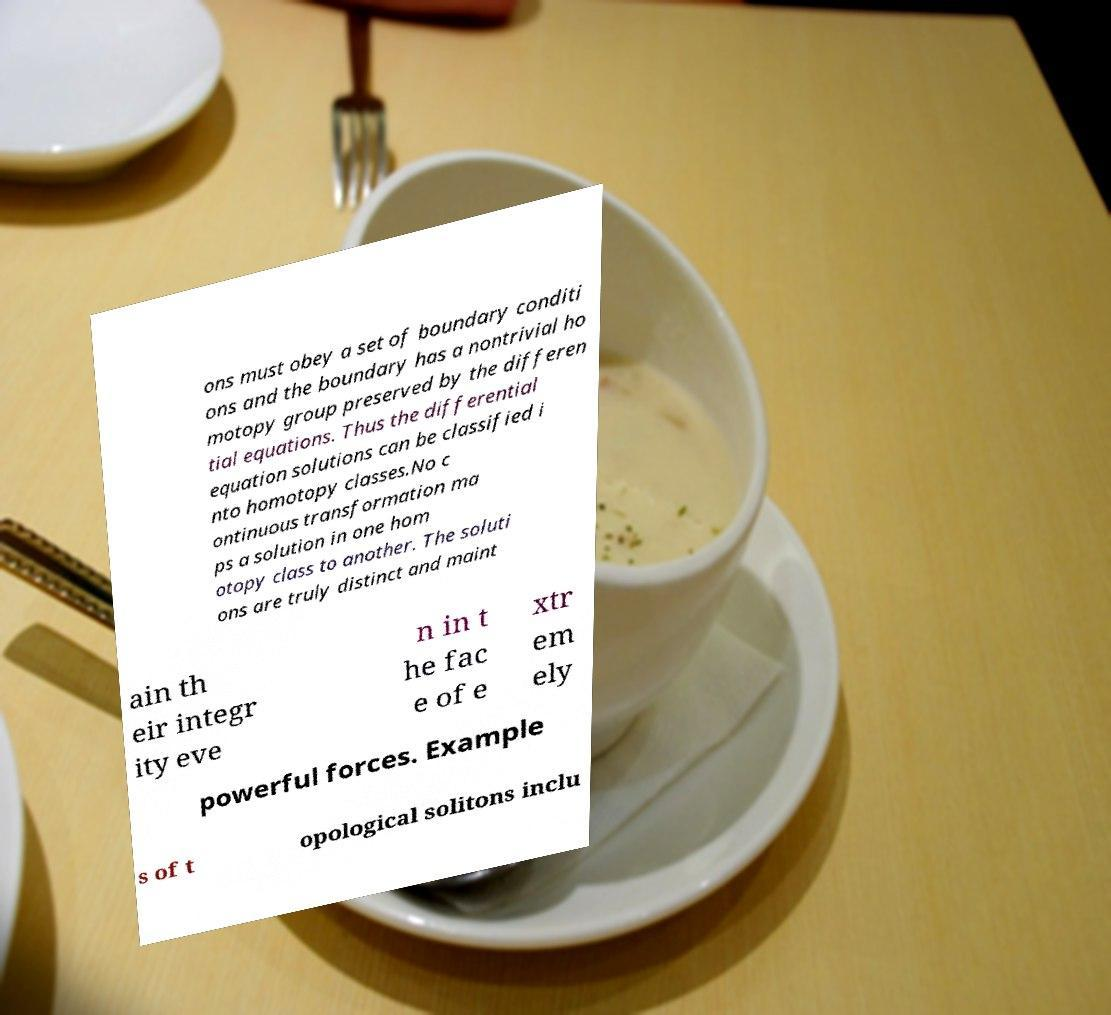Could you assist in decoding the text presented in this image and type it out clearly? ons must obey a set of boundary conditi ons and the boundary has a nontrivial ho motopy group preserved by the differen tial equations. Thus the differential equation solutions can be classified i nto homotopy classes.No c ontinuous transformation ma ps a solution in one hom otopy class to another. The soluti ons are truly distinct and maint ain th eir integr ity eve n in t he fac e of e xtr em ely powerful forces. Example s of t opological solitons inclu 